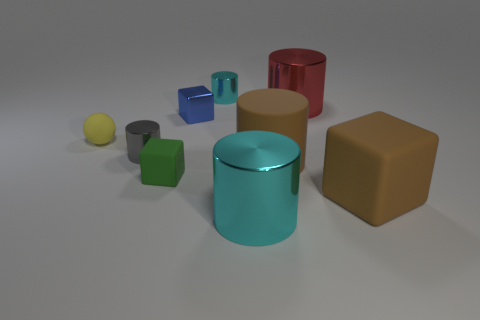What is the material of the tiny block in front of the rubber sphere?
Make the answer very short. Rubber. What is the color of the cylinder that is in front of the tiny blue cube and right of the large cyan metallic object?
Give a very brief answer. Brown. What number of other objects are there of the same color as the tiny rubber sphere?
Your answer should be compact. 0. What color is the large metal object that is behind the large cyan object?
Your answer should be very brief. Red. Is there a red metal block of the same size as the yellow matte object?
Provide a short and direct response. No. There is a green object that is the same size as the blue cube; what is it made of?
Provide a short and direct response. Rubber. What number of things are either tiny cyan shiny objects behind the large brown cylinder or big cylinders to the left of the big red cylinder?
Provide a succinct answer. 3. Is there a large blue object that has the same shape as the red shiny thing?
Give a very brief answer. No. There is a large object that is the same color as the big cube; what material is it?
Ensure brevity in your answer.  Rubber. What number of shiny objects are tiny gray cylinders or big red things?
Provide a short and direct response. 2. 